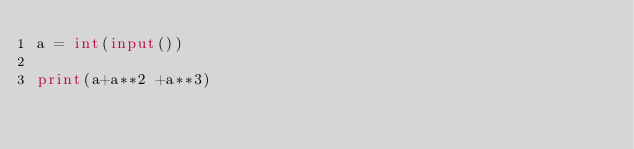<code> <loc_0><loc_0><loc_500><loc_500><_Python_>a = int(input())

print(a+a**2 +a**3)</code> 